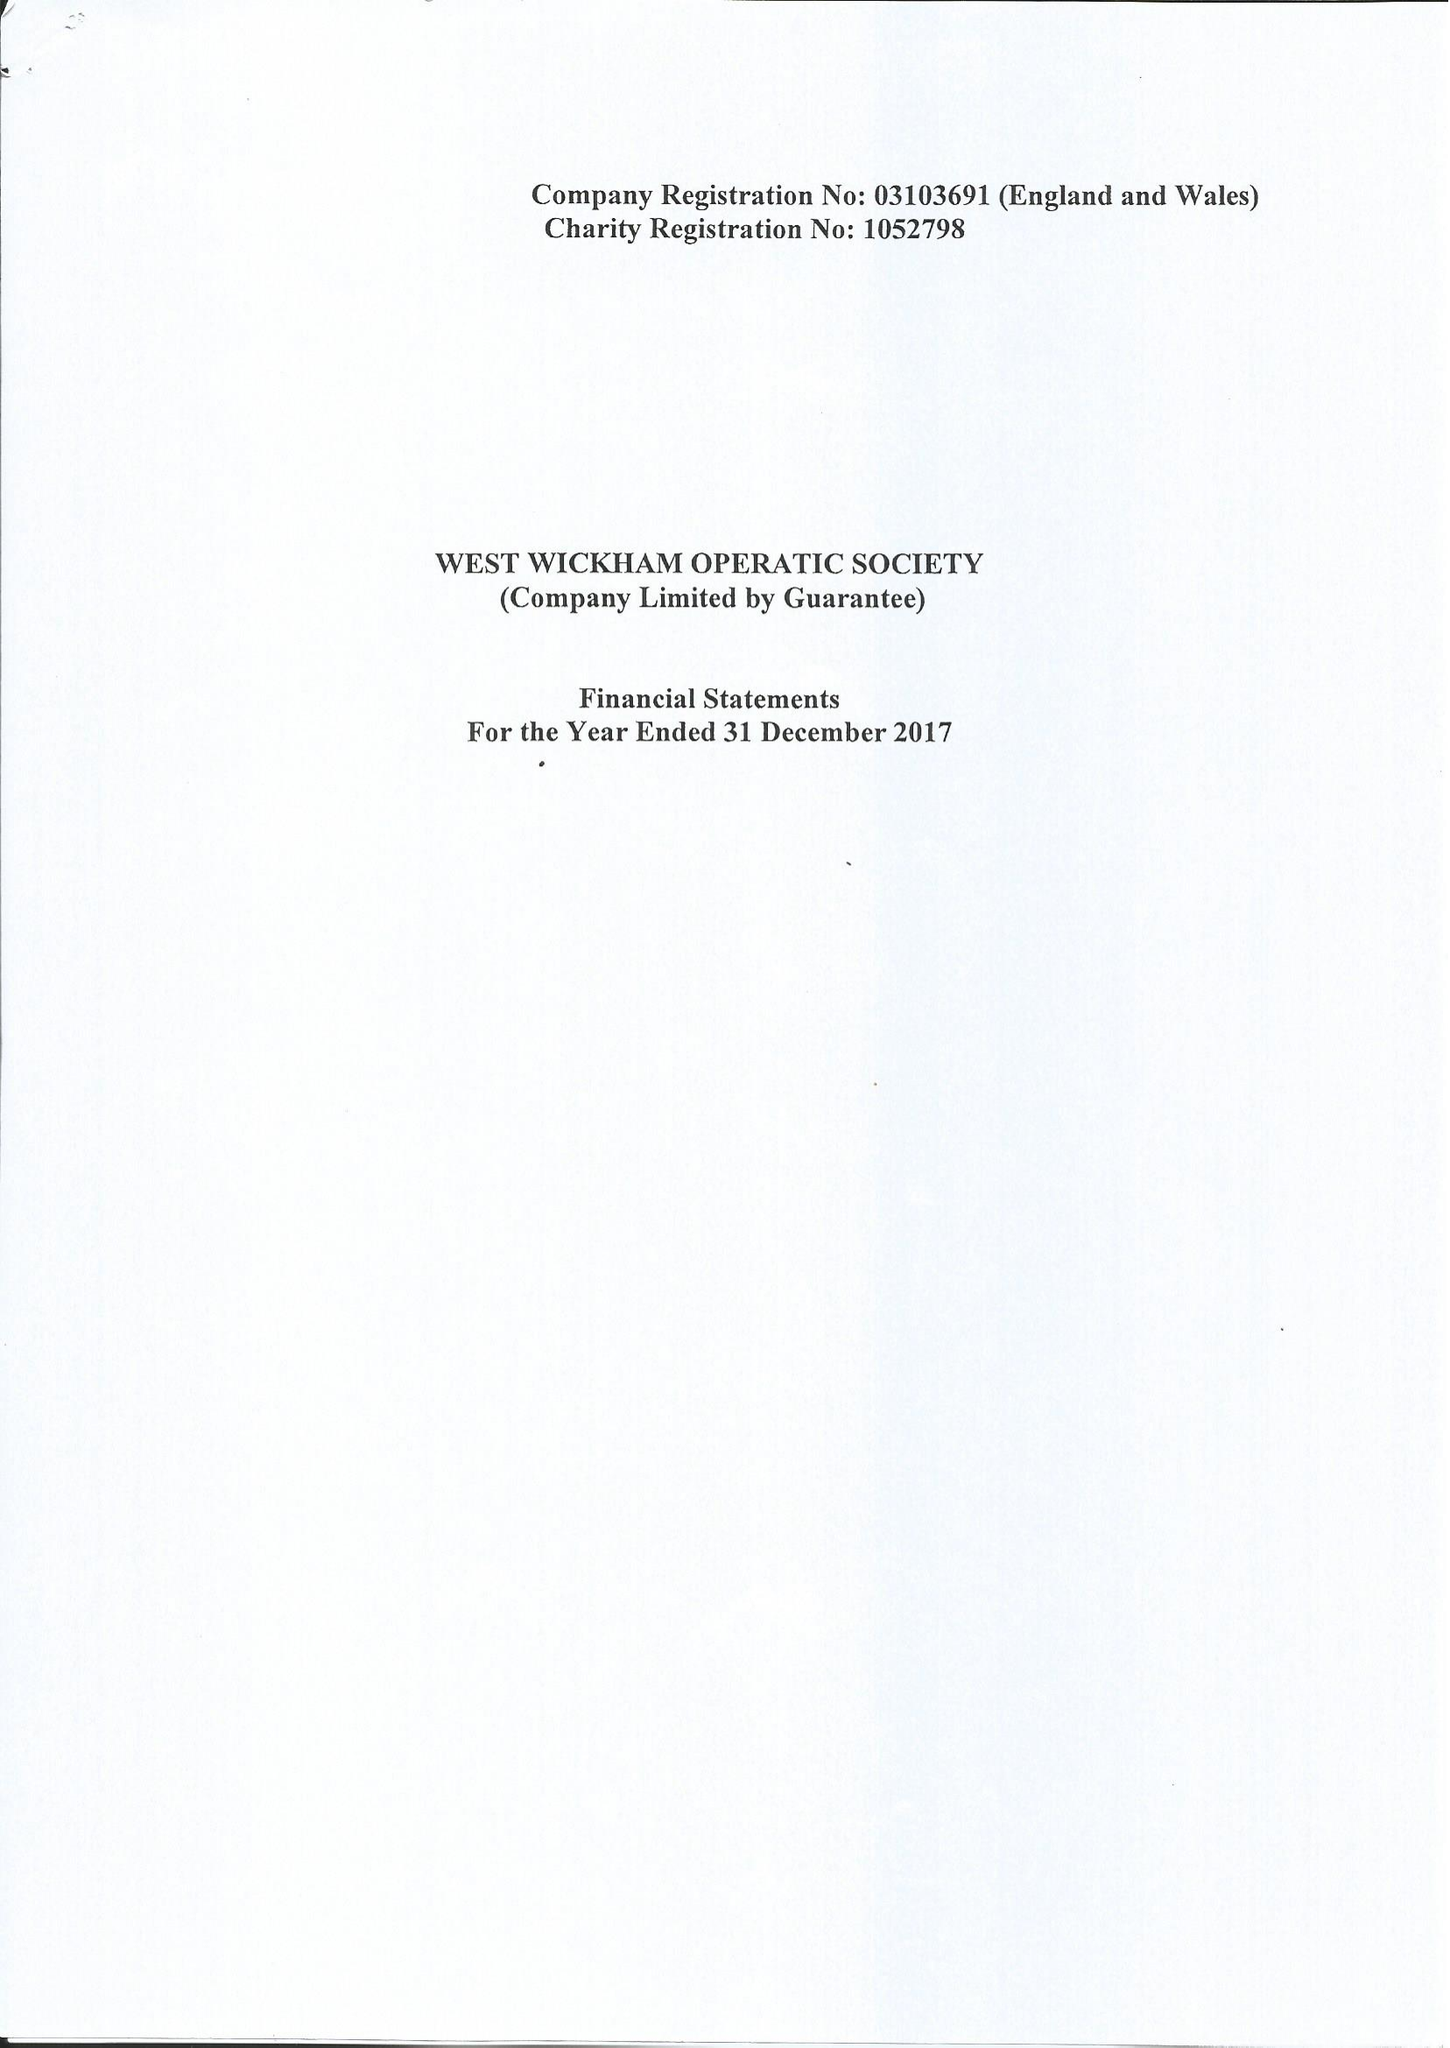What is the value for the address__street_line?
Answer the question using a single word or phrase. 27 COURT DOWNS ROAD 